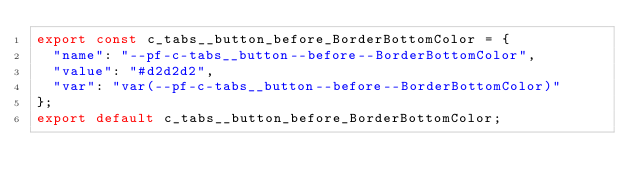Convert code to text. <code><loc_0><loc_0><loc_500><loc_500><_JavaScript_>export const c_tabs__button_before_BorderBottomColor = {
  "name": "--pf-c-tabs__button--before--BorderBottomColor",
  "value": "#d2d2d2",
  "var": "var(--pf-c-tabs__button--before--BorderBottomColor)"
};
export default c_tabs__button_before_BorderBottomColor;</code> 